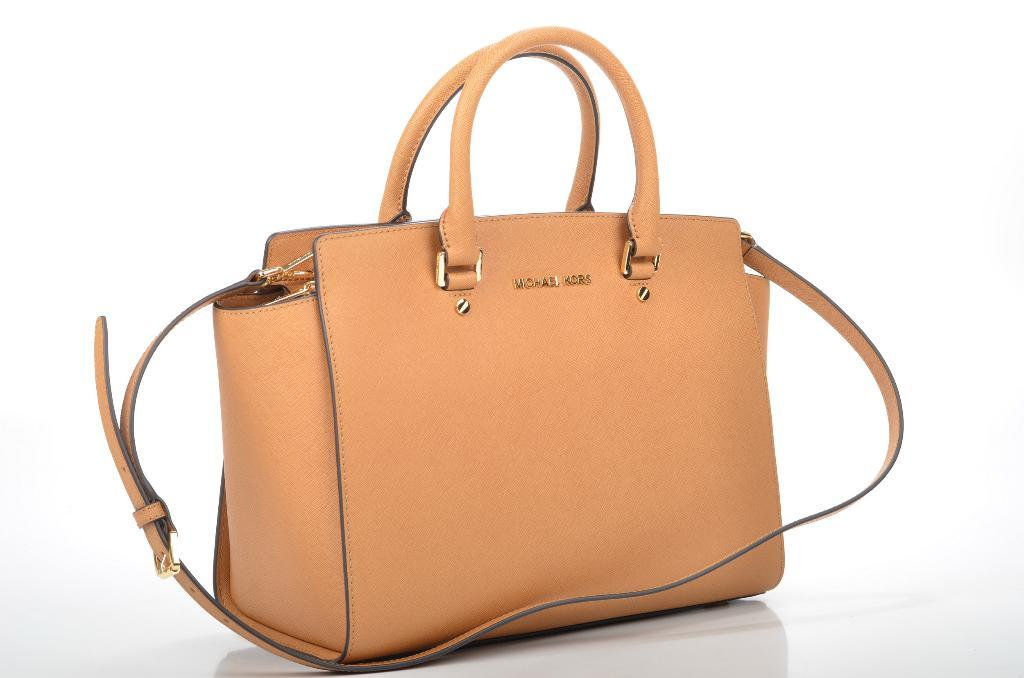What is present in the picture? There is a bag in the picture. What color is the bag? The bag is orange in color. What brand is the bag from? The bag is from Michael Kors. Where is the badge located in the image? There is no badge present in the image. What type of playground equipment can be seen in the image? There is no playground equipment present in the image. 